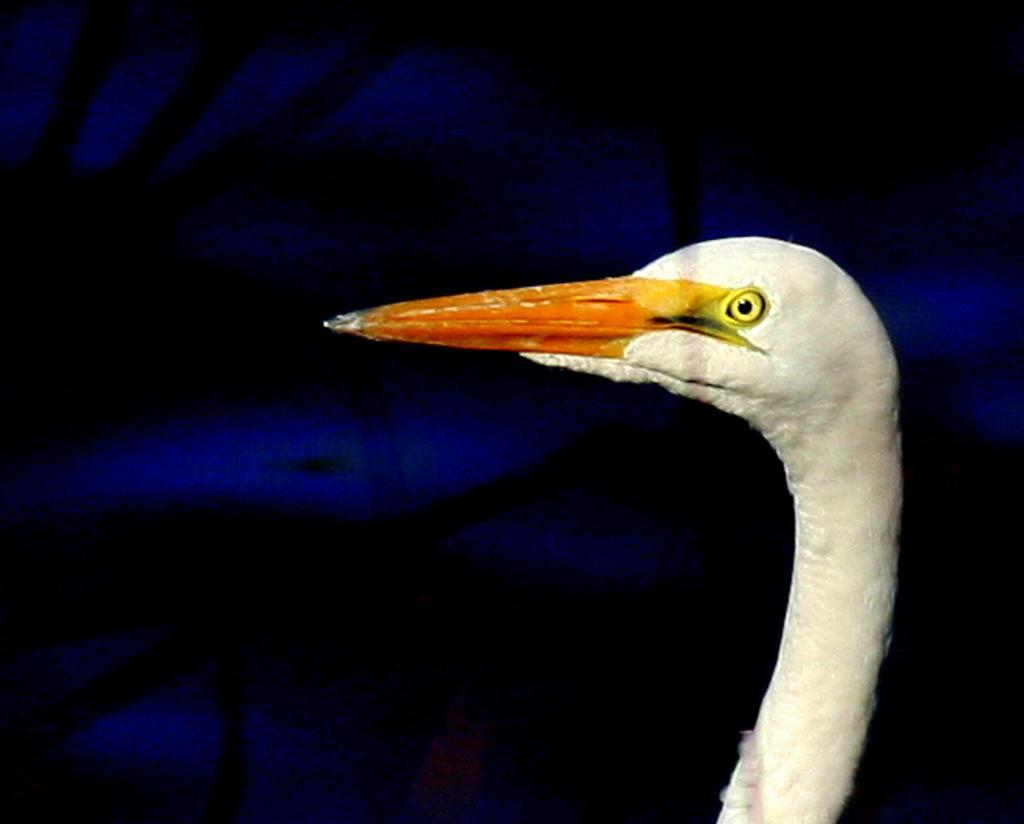Could you give a brief overview of what you see in this image? In the image we can see a bird. 